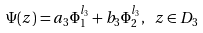<formula> <loc_0><loc_0><loc_500><loc_500>\Psi ( z ) = a _ { 3 } \Phi ^ { l _ { 3 } } _ { 1 } + b _ { 3 } \Phi ^ { l _ { 3 } } _ { 2 } , \ z \in D _ { 3 }</formula> 